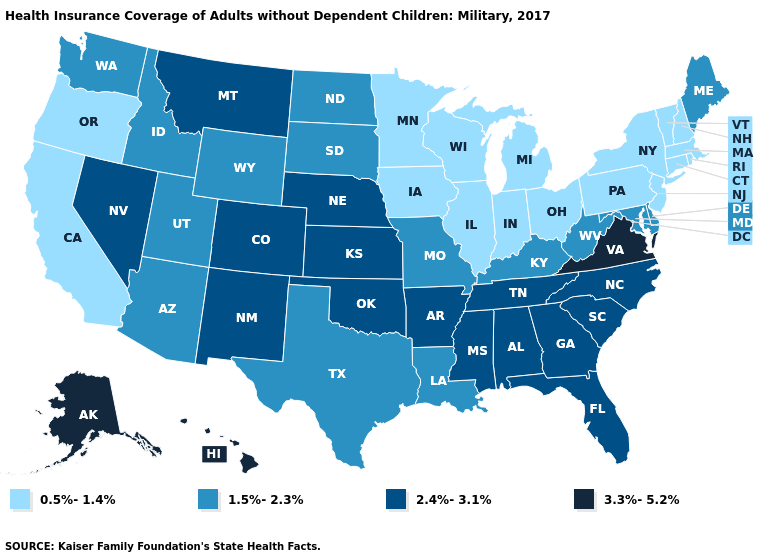Does Minnesota have the lowest value in the USA?
Concise answer only. Yes. What is the lowest value in states that border New Hampshire?
Short answer required. 0.5%-1.4%. Name the states that have a value in the range 1.5%-2.3%?
Give a very brief answer. Arizona, Delaware, Idaho, Kentucky, Louisiana, Maine, Maryland, Missouri, North Dakota, South Dakota, Texas, Utah, Washington, West Virginia, Wyoming. Name the states that have a value in the range 2.4%-3.1%?
Short answer required. Alabama, Arkansas, Colorado, Florida, Georgia, Kansas, Mississippi, Montana, Nebraska, Nevada, New Mexico, North Carolina, Oklahoma, South Carolina, Tennessee. Which states have the lowest value in the West?
Be succinct. California, Oregon. Name the states that have a value in the range 2.4%-3.1%?
Short answer required. Alabama, Arkansas, Colorado, Florida, Georgia, Kansas, Mississippi, Montana, Nebraska, Nevada, New Mexico, North Carolina, Oklahoma, South Carolina, Tennessee. What is the lowest value in the MidWest?
Write a very short answer. 0.5%-1.4%. Name the states that have a value in the range 1.5%-2.3%?
Short answer required. Arizona, Delaware, Idaho, Kentucky, Louisiana, Maine, Maryland, Missouri, North Dakota, South Dakota, Texas, Utah, Washington, West Virginia, Wyoming. What is the highest value in the Northeast ?
Quick response, please. 1.5%-2.3%. What is the value of Connecticut?
Give a very brief answer. 0.5%-1.4%. Name the states that have a value in the range 0.5%-1.4%?
Short answer required. California, Connecticut, Illinois, Indiana, Iowa, Massachusetts, Michigan, Minnesota, New Hampshire, New Jersey, New York, Ohio, Oregon, Pennsylvania, Rhode Island, Vermont, Wisconsin. Which states hav the highest value in the Northeast?
Answer briefly. Maine. Among the states that border North Carolina , which have the highest value?
Concise answer only. Virginia. Among the states that border Tennessee , which have the highest value?
Short answer required. Virginia. Does Pennsylvania have the lowest value in the Northeast?
Write a very short answer. Yes. 